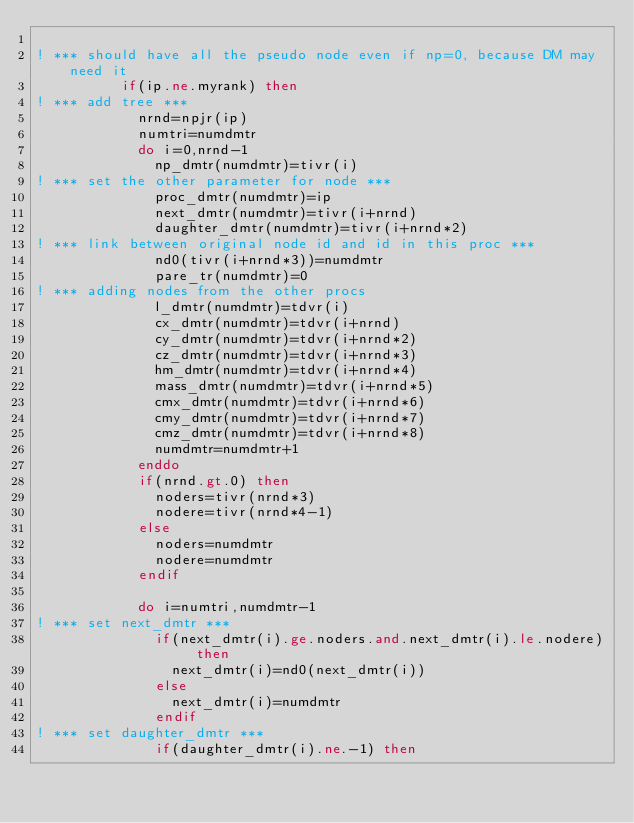Convert code to text. <code><loc_0><loc_0><loc_500><loc_500><_FORTRAN_>
! *** should have all the pseudo node even if np=0, because DM may need it
          if(ip.ne.myrank) then
! *** add tree ***
            nrnd=npjr(ip)
            numtri=numdmtr
            do i=0,nrnd-1
              np_dmtr(numdmtr)=tivr(i)
! *** set the other parameter for node ***
              proc_dmtr(numdmtr)=ip
              next_dmtr(numdmtr)=tivr(i+nrnd)
              daughter_dmtr(numdmtr)=tivr(i+nrnd*2)
! *** link between original node id and id in this proc ***
              nd0(tivr(i+nrnd*3))=numdmtr
              pare_tr(numdmtr)=0
! *** adding nodes from the other procs
              l_dmtr(numdmtr)=tdvr(i)
              cx_dmtr(numdmtr)=tdvr(i+nrnd)
              cy_dmtr(numdmtr)=tdvr(i+nrnd*2)
              cz_dmtr(numdmtr)=tdvr(i+nrnd*3)
              hm_dmtr(numdmtr)=tdvr(i+nrnd*4)
              mass_dmtr(numdmtr)=tdvr(i+nrnd*5)
              cmx_dmtr(numdmtr)=tdvr(i+nrnd*6)
              cmy_dmtr(numdmtr)=tdvr(i+nrnd*7)
              cmz_dmtr(numdmtr)=tdvr(i+nrnd*8)
              numdmtr=numdmtr+1
            enddo
            if(nrnd.gt.0) then
              noders=tivr(nrnd*3)
              nodere=tivr(nrnd*4-1)
            else
              noders=numdmtr
              nodere=numdmtr
            endif

            do i=numtri,numdmtr-1
! *** set next_dmtr ***
              if(next_dmtr(i).ge.noders.and.next_dmtr(i).le.nodere) then
                next_dmtr(i)=nd0(next_dmtr(i))
              else
                next_dmtr(i)=numdmtr
              endif
! *** set daughter_dmtr ***     
              if(daughter_dmtr(i).ne.-1) then</code> 